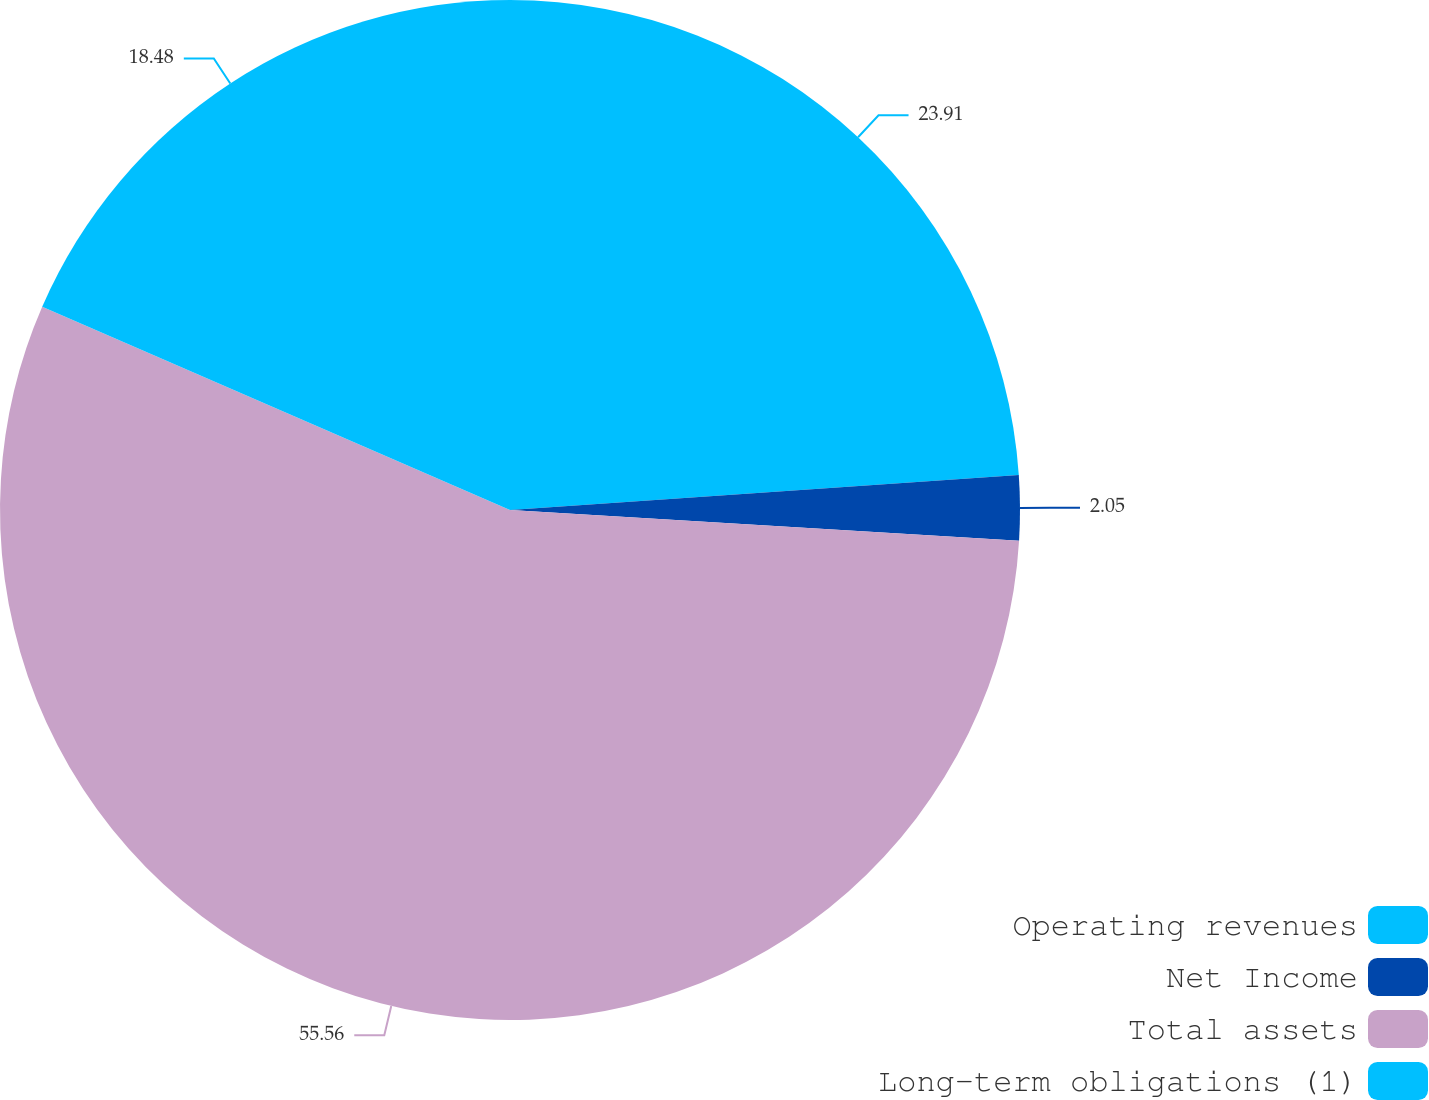<chart> <loc_0><loc_0><loc_500><loc_500><pie_chart><fcel>Operating revenues<fcel>Net Income<fcel>Total assets<fcel>Long-term obligations (1)<nl><fcel>23.91%<fcel>2.05%<fcel>55.56%<fcel>18.48%<nl></chart> 